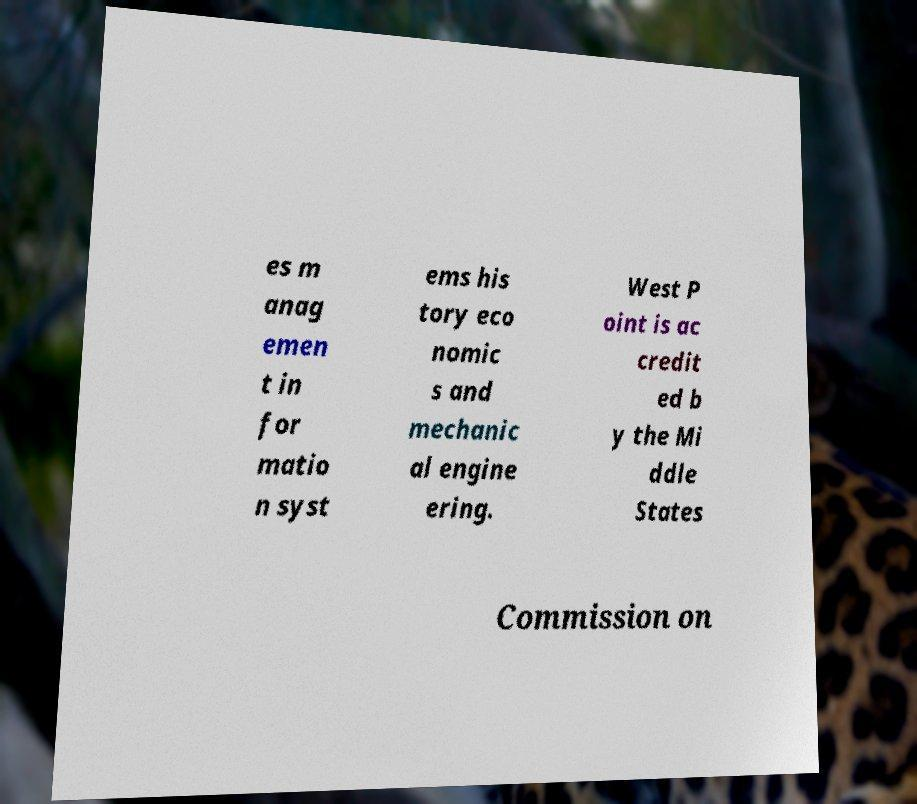Could you assist in decoding the text presented in this image and type it out clearly? es m anag emen t in for matio n syst ems his tory eco nomic s and mechanic al engine ering. West P oint is ac credit ed b y the Mi ddle States Commission on 